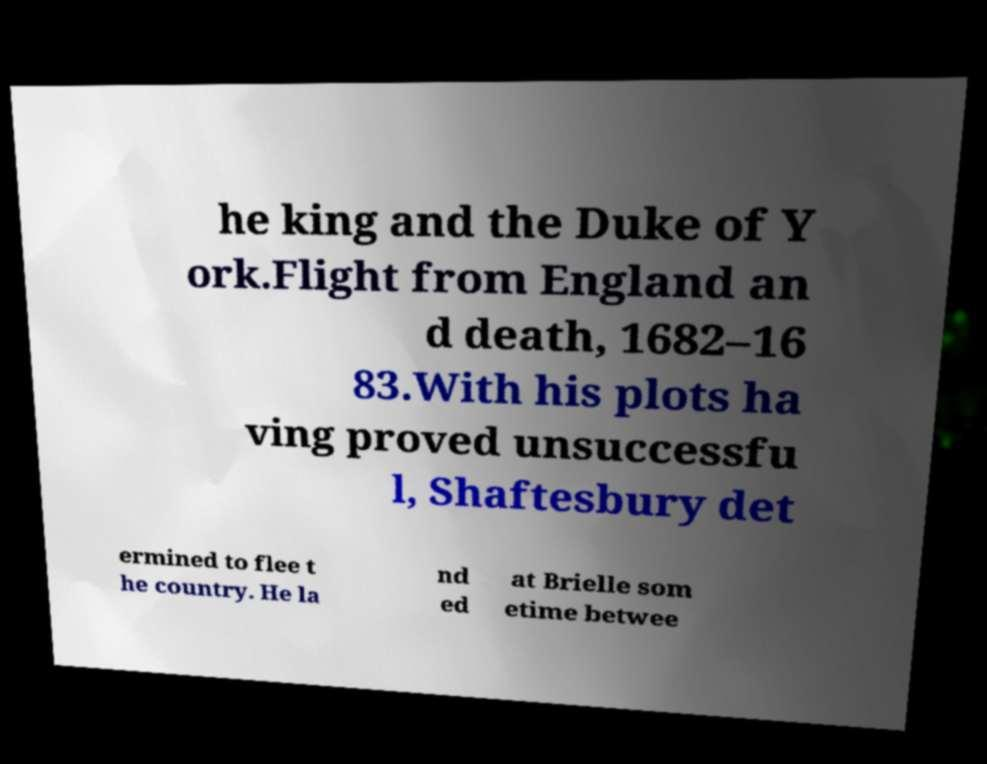Could you assist in decoding the text presented in this image and type it out clearly? he king and the Duke of Y ork.Flight from England an d death, 1682–16 83.With his plots ha ving proved unsuccessfu l, Shaftesbury det ermined to flee t he country. He la nd ed at Brielle som etime betwee 